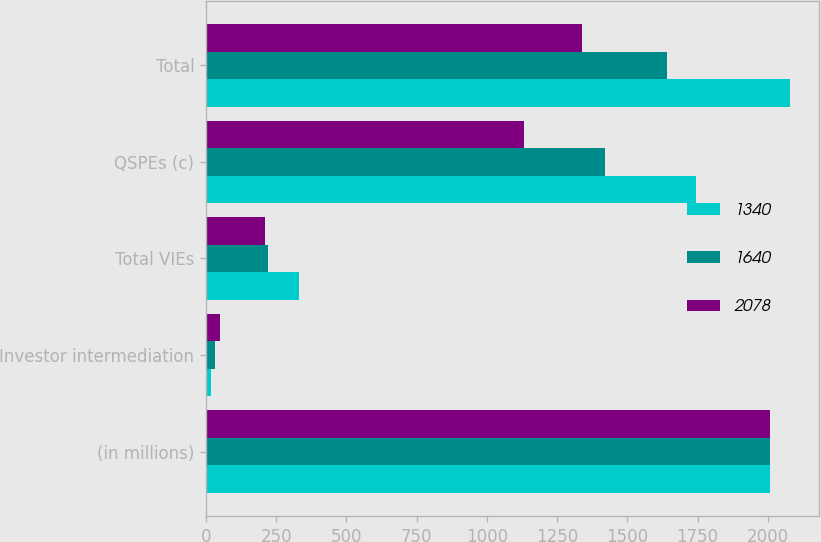<chart> <loc_0><loc_0><loc_500><loc_500><stacked_bar_chart><ecel><fcel>(in millions)<fcel>Investor intermediation<fcel>Total VIEs<fcel>QSPEs (c)<fcel>Total<nl><fcel>1340<fcel>2008<fcel>18<fcel>332<fcel>1746<fcel>2078<nl><fcel>1640<fcel>2007<fcel>33<fcel>220<fcel>1420<fcel>1640<nl><fcel>2078<fcel>2006<fcel>49<fcel>209<fcel>1131<fcel>1340<nl></chart> 